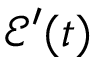Convert formula to latex. <formula><loc_0><loc_0><loc_500><loc_500>\mathcal { E } ^ { \prime } ( t )</formula> 